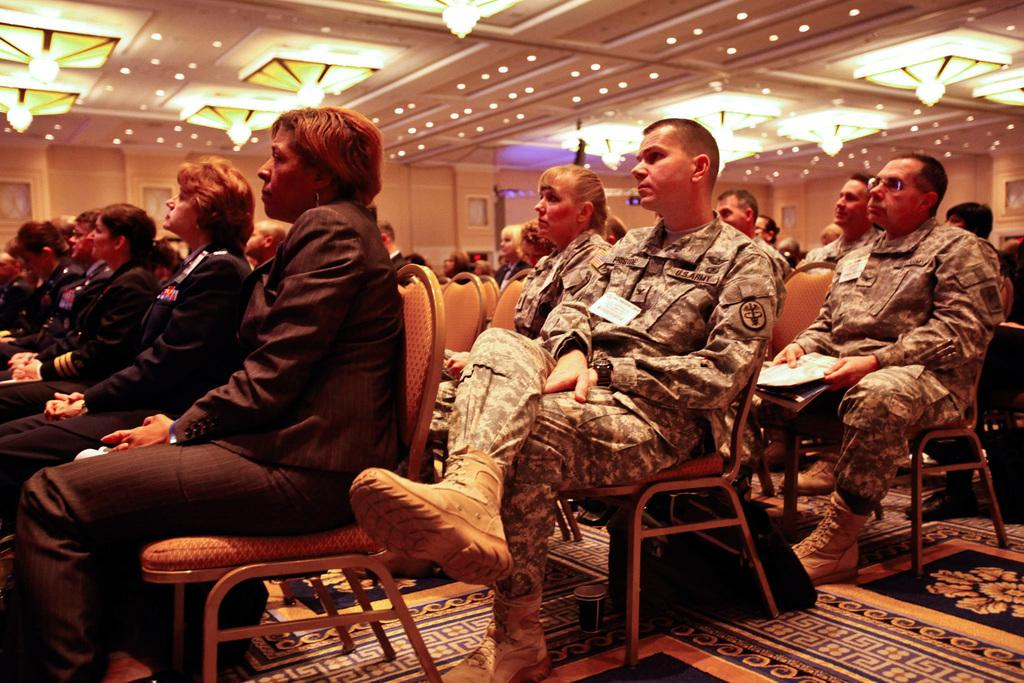What are the people in the image doing? The people in the image are sitting on chairs. Can you describe the carpet in the image? The carpet in the image is black and yellowish in color. How many dogs are present in the image? There are no dogs present in the image. Who is wearing the crown in the image? There is no crown present in the image. 